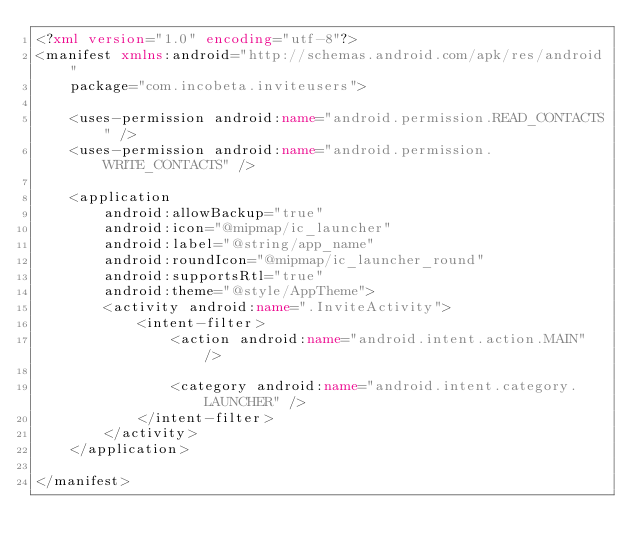Convert code to text. <code><loc_0><loc_0><loc_500><loc_500><_XML_><?xml version="1.0" encoding="utf-8"?>
<manifest xmlns:android="http://schemas.android.com/apk/res/android"
    package="com.incobeta.inviteusers">

    <uses-permission android:name="android.permission.READ_CONTACTS" />
    <uses-permission android:name="android.permission.WRITE_CONTACTS" />

    <application
        android:allowBackup="true"
        android:icon="@mipmap/ic_launcher"
        android:label="@string/app_name"
        android:roundIcon="@mipmap/ic_launcher_round"
        android:supportsRtl="true"
        android:theme="@style/AppTheme">
        <activity android:name=".InviteActivity">
            <intent-filter>
                <action android:name="android.intent.action.MAIN" />

                <category android:name="android.intent.category.LAUNCHER" />
            </intent-filter>
        </activity>
    </application>

</manifest></code> 